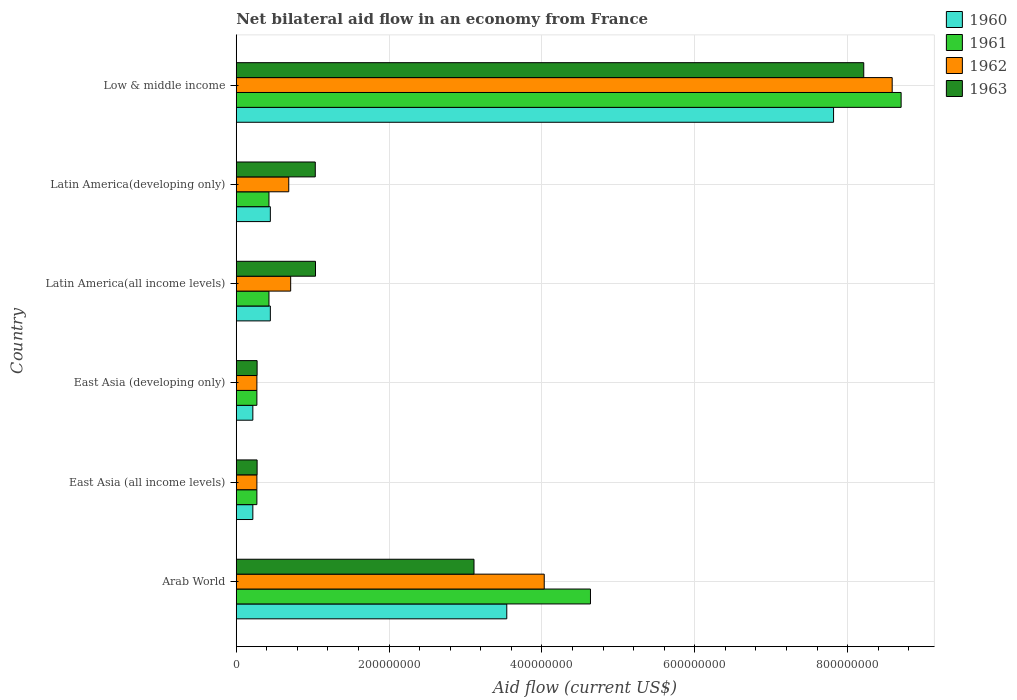Are the number of bars on each tick of the Y-axis equal?
Keep it short and to the point. Yes. How many bars are there on the 3rd tick from the top?
Your response must be concise. 4. What is the label of the 5th group of bars from the top?
Provide a succinct answer. East Asia (all income levels). What is the net bilateral aid flow in 1960 in Latin America(all income levels)?
Provide a succinct answer. 4.46e+07. Across all countries, what is the maximum net bilateral aid flow in 1960?
Your response must be concise. 7.82e+08. Across all countries, what is the minimum net bilateral aid flow in 1962?
Keep it short and to the point. 2.70e+07. In which country was the net bilateral aid flow in 1960 maximum?
Your response must be concise. Low & middle income. In which country was the net bilateral aid flow in 1961 minimum?
Ensure brevity in your answer.  East Asia (all income levels). What is the total net bilateral aid flow in 1961 in the graph?
Provide a succinct answer. 1.47e+09. What is the difference between the net bilateral aid flow in 1961 in East Asia (developing only) and that in Low & middle income?
Provide a short and direct response. -8.43e+08. What is the difference between the net bilateral aid flow in 1962 in Arab World and the net bilateral aid flow in 1960 in Latin America(all income levels)?
Ensure brevity in your answer.  3.58e+08. What is the average net bilateral aid flow in 1962 per country?
Ensure brevity in your answer.  2.43e+08. What is the difference between the net bilateral aid flow in 1960 and net bilateral aid flow in 1963 in East Asia (developing only)?
Your response must be concise. -5.60e+06. In how many countries, is the net bilateral aid flow in 1961 greater than 240000000 US$?
Offer a very short reply. 2. What is the ratio of the net bilateral aid flow in 1961 in Arab World to that in East Asia (developing only)?
Your answer should be compact. 17.17. What is the difference between the highest and the second highest net bilateral aid flow in 1960?
Ensure brevity in your answer.  4.28e+08. What is the difference between the highest and the lowest net bilateral aid flow in 1962?
Keep it short and to the point. 8.31e+08. In how many countries, is the net bilateral aid flow in 1960 greater than the average net bilateral aid flow in 1960 taken over all countries?
Keep it short and to the point. 2. Is the sum of the net bilateral aid flow in 1962 in Latin America(all income levels) and Latin America(developing only) greater than the maximum net bilateral aid flow in 1960 across all countries?
Your response must be concise. No. Is it the case that in every country, the sum of the net bilateral aid flow in 1961 and net bilateral aid flow in 1963 is greater than the sum of net bilateral aid flow in 1962 and net bilateral aid flow in 1960?
Keep it short and to the point. No. Is it the case that in every country, the sum of the net bilateral aid flow in 1962 and net bilateral aid flow in 1963 is greater than the net bilateral aid flow in 1961?
Make the answer very short. Yes. What is the difference between two consecutive major ticks on the X-axis?
Your response must be concise. 2.00e+08. Are the values on the major ticks of X-axis written in scientific E-notation?
Keep it short and to the point. No. Does the graph contain grids?
Ensure brevity in your answer.  Yes. How many legend labels are there?
Your response must be concise. 4. What is the title of the graph?
Give a very brief answer. Net bilateral aid flow in an economy from France. Does "2012" appear as one of the legend labels in the graph?
Provide a succinct answer. No. What is the label or title of the Y-axis?
Make the answer very short. Country. What is the Aid flow (current US$) in 1960 in Arab World?
Your answer should be very brief. 3.54e+08. What is the Aid flow (current US$) in 1961 in Arab World?
Keep it short and to the point. 4.64e+08. What is the Aid flow (current US$) in 1962 in Arab World?
Your answer should be very brief. 4.03e+08. What is the Aid flow (current US$) of 1963 in Arab World?
Your response must be concise. 3.11e+08. What is the Aid flow (current US$) of 1960 in East Asia (all income levels)?
Provide a short and direct response. 2.17e+07. What is the Aid flow (current US$) in 1961 in East Asia (all income levels)?
Your answer should be very brief. 2.70e+07. What is the Aid flow (current US$) in 1962 in East Asia (all income levels)?
Offer a very short reply. 2.70e+07. What is the Aid flow (current US$) in 1963 in East Asia (all income levels)?
Your response must be concise. 2.73e+07. What is the Aid flow (current US$) in 1960 in East Asia (developing only)?
Offer a very short reply. 2.17e+07. What is the Aid flow (current US$) of 1961 in East Asia (developing only)?
Give a very brief answer. 2.70e+07. What is the Aid flow (current US$) of 1962 in East Asia (developing only)?
Offer a very short reply. 2.70e+07. What is the Aid flow (current US$) of 1963 in East Asia (developing only)?
Your response must be concise. 2.73e+07. What is the Aid flow (current US$) in 1960 in Latin America(all income levels)?
Give a very brief answer. 4.46e+07. What is the Aid flow (current US$) of 1961 in Latin America(all income levels)?
Your answer should be very brief. 4.28e+07. What is the Aid flow (current US$) of 1962 in Latin America(all income levels)?
Ensure brevity in your answer.  7.12e+07. What is the Aid flow (current US$) in 1963 in Latin America(all income levels)?
Your response must be concise. 1.04e+08. What is the Aid flow (current US$) in 1960 in Latin America(developing only)?
Offer a very short reply. 4.46e+07. What is the Aid flow (current US$) in 1961 in Latin America(developing only)?
Offer a terse response. 4.28e+07. What is the Aid flow (current US$) of 1962 in Latin America(developing only)?
Keep it short and to the point. 6.87e+07. What is the Aid flow (current US$) in 1963 in Latin America(developing only)?
Provide a succinct answer. 1.03e+08. What is the Aid flow (current US$) in 1960 in Low & middle income?
Keep it short and to the point. 7.82e+08. What is the Aid flow (current US$) in 1961 in Low & middle income?
Your response must be concise. 8.70e+08. What is the Aid flow (current US$) of 1962 in Low & middle income?
Offer a terse response. 8.58e+08. What is the Aid flow (current US$) of 1963 in Low & middle income?
Your answer should be compact. 8.21e+08. Across all countries, what is the maximum Aid flow (current US$) in 1960?
Ensure brevity in your answer.  7.82e+08. Across all countries, what is the maximum Aid flow (current US$) in 1961?
Your answer should be compact. 8.70e+08. Across all countries, what is the maximum Aid flow (current US$) of 1962?
Offer a terse response. 8.58e+08. Across all countries, what is the maximum Aid flow (current US$) in 1963?
Offer a terse response. 8.21e+08. Across all countries, what is the minimum Aid flow (current US$) in 1960?
Your response must be concise. 2.17e+07. Across all countries, what is the minimum Aid flow (current US$) of 1961?
Provide a succinct answer. 2.70e+07. Across all countries, what is the minimum Aid flow (current US$) of 1962?
Your answer should be compact. 2.70e+07. Across all countries, what is the minimum Aid flow (current US$) of 1963?
Give a very brief answer. 2.73e+07. What is the total Aid flow (current US$) of 1960 in the graph?
Ensure brevity in your answer.  1.27e+09. What is the total Aid flow (current US$) of 1961 in the graph?
Your response must be concise. 1.47e+09. What is the total Aid flow (current US$) of 1962 in the graph?
Your answer should be very brief. 1.46e+09. What is the total Aid flow (current US$) in 1963 in the graph?
Offer a terse response. 1.39e+09. What is the difference between the Aid flow (current US$) of 1960 in Arab World and that in East Asia (all income levels)?
Offer a terse response. 3.32e+08. What is the difference between the Aid flow (current US$) of 1961 in Arab World and that in East Asia (all income levels)?
Keep it short and to the point. 4.36e+08. What is the difference between the Aid flow (current US$) of 1962 in Arab World and that in East Asia (all income levels)?
Ensure brevity in your answer.  3.76e+08. What is the difference between the Aid flow (current US$) in 1963 in Arab World and that in East Asia (all income levels)?
Your answer should be very brief. 2.84e+08. What is the difference between the Aid flow (current US$) in 1960 in Arab World and that in East Asia (developing only)?
Offer a very short reply. 3.32e+08. What is the difference between the Aid flow (current US$) of 1961 in Arab World and that in East Asia (developing only)?
Your answer should be very brief. 4.36e+08. What is the difference between the Aid flow (current US$) in 1962 in Arab World and that in East Asia (developing only)?
Provide a succinct answer. 3.76e+08. What is the difference between the Aid flow (current US$) in 1963 in Arab World and that in East Asia (developing only)?
Provide a short and direct response. 2.84e+08. What is the difference between the Aid flow (current US$) of 1960 in Arab World and that in Latin America(all income levels)?
Ensure brevity in your answer.  3.09e+08. What is the difference between the Aid flow (current US$) of 1961 in Arab World and that in Latin America(all income levels)?
Ensure brevity in your answer.  4.21e+08. What is the difference between the Aid flow (current US$) in 1962 in Arab World and that in Latin America(all income levels)?
Offer a terse response. 3.32e+08. What is the difference between the Aid flow (current US$) in 1963 in Arab World and that in Latin America(all income levels)?
Keep it short and to the point. 2.07e+08. What is the difference between the Aid flow (current US$) of 1960 in Arab World and that in Latin America(developing only)?
Keep it short and to the point. 3.09e+08. What is the difference between the Aid flow (current US$) of 1961 in Arab World and that in Latin America(developing only)?
Your response must be concise. 4.21e+08. What is the difference between the Aid flow (current US$) of 1962 in Arab World and that in Latin America(developing only)?
Provide a short and direct response. 3.34e+08. What is the difference between the Aid flow (current US$) of 1963 in Arab World and that in Latin America(developing only)?
Give a very brief answer. 2.08e+08. What is the difference between the Aid flow (current US$) of 1960 in Arab World and that in Low & middle income?
Provide a succinct answer. -4.28e+08. What is the difference between the Aid flow (current US$) of 1961 in Arab World and that in Low & middle income?
Offer a very short reply. -4.06e+08. What is the difference between the Aid flow (current US$) of 1962 in Arab World and that in Low & middle income?
Keep it short and to the point. -4.55e+08. What is the difference between the Aid flow (current US$) of 1963 in Arab World and that in Low & middle income?
Give a very brief answer. -5.10e+08. What is the difference between the Aid flow (current US$) of 1960 in East Asia (all income levels) and that in Latin America(all income levels)?
Keep it short and to the point. -2.29e+07. What is the difference between the Aid flow (current US$) of 1961 in East Asia (all income levels) and that in Latin America(all income levels)?
Provide a short and direct response. -1.58e+07. What is the difference between the Aid flow (current US$) in 1962 in East Asia (all income levels) and that in Latin America(all income levels)?
Provide a short and direct response. -4.42e+07. What is the difference between the Aid flow (current US$) of 1963 in East Asia (all income levels) and that in Latin America(all income levels)?
Your answer should be very brief. -7.64e+07. What is the difference between the Aid flow (current US$) in 1960 in East Asia (all income levels) and that in Latin America(developing only)?
Your answer should be compact. -2.29e+07. What is the difference between the Aid flow (current US$) in 1961 in East Asia (all income levels) and that in Latin America(developing only)?
Offer a terse response. -1.58e+07. What is the difference between the Aid flow (current US$) in 1962 in East Asia (all income levels) and that in Latin America(developing only)?
Your answer should be very brief. -4.17e+07. What is the difference between the Aid flow (current US$) in 1963 in East Asia (all income levels) and that in Latin America(developing only)?
Your answer should be very brief. -7.61e+07. What is the difference between the Aid flow (current US$) in 1960 in East Asia (all income levels) and that in Low & middle income?
Provide a succinct answer. -7.60e+08. What is the difference between the Aid flow (current US$) of 1961 in East Asia (all income levels) and that in Low & middle income?
Keep it short and to the point. -8.43e+08. What is the difference between the Aid flow (current US$) of 1962 in East Asia (all income levels) and that in Low & middle income?
Make the answer very short. -8.31e+08. What is the difference between the Aid flow (current US$) in 1963 in East Asia (all income levels) and that in Low & middle income?
Offer a terse response. -7.94e+08. What is the difference between the Aid flow (current US$) of 1960 in East Asia (developing only) and that in Latin America(all income levels)?
Your answer should be very brief. -2.29e+07. What is the difference between the Aid flow (current US$) of 1961 in East Asia (developing only) and that in Latin America(all income levels)?
Give a very brief answer. -1.58e+07. What is the difference between the Aid flow (current US$) in 1962 in East Asia (developing only) and that in Latin America(all income levels)?
Ensure brevity in your answer.  -4.42e+07. What is the difference between the Aid flow (current US$) of 1963 in East Asia (developing only) and that in Latin America(all income levels)?
Ensure brevity in your answer.  -7.64e+07. What is the difference between the Aid flow (current US$) in 1960 in East Asia (developing only) and that in Latin America(developing only)?
Make the answer very short. -2.29e+07. What is the difference between the Aid flow (current US$) in 1961 in East Asia (developing only) and that in Latin America(developing only)?
Give a very brief answer. -1.58e+07. What is the difference between the Aid flow (current US$) in 1962 in East Asia (developing only) and that in Latin America(developing only)?
Ensure brevity in your answer.  -4.17e+07. What is the difference between the Aid flow (current US$) of 1963 in East Asia (developing only) and that in Latin America(developing only)?
Keep it short and to the point. -7.61e+07. What is the difference between the Aid flow (current US$) of 1960 in East Asia (developing only) and that in Low & middle income?
Your response must be concise. -7.60e+08. What is the difference between the Aid flow (current US$) of 1961 in East Asia (developing only) and that in Low & middle income?
Keep it short and to the point. -8.43e+08. What is the difference between the Aid flow (current US$) of 1962 in East Asia (developing only) and that in Low & middle income?
Provide a succinct answer. -8.31e+08. What is the difference between the Aid flow (current US$) of 1963 in East Asia (developing only) and that in Low & middle income?
Offer a terse response. -7.94e+08. What is the difference between the Aid flow (current US$) of 1961 in Latin America(all income levels) and that in Latin America(developing only)?
Offer a very short reply. 0. What is the difference between the Aid flow (current US$) of 1962 in Latin America(all income levels) and that in Latin America(developing only)?
Provide a succinct answer. 2.50e+06. What is the difference between the Aid flow (current US$) of 1960 in Latin America(all income levels) and that in Low & middle income?
Ensure brevity in your answer.  -7.37e+08. What is the difference between the Aid flow (current US$) of 1961 in Latin America(all income levels) and that in Low & middle income?
Ensure brevity in your answer.  -8.27e+08. What is the difference between the Aid flow (current US$) in 1962 in Latin America(all income levels) and that in Low & middle income?
Provide a succinct answer. -7.87e+08. What is the difference between the Aid flow (current US$) of 1963 in Latin America(all income levels) and that in Low & middle income?
Give a very brief answer. -7.17e+08. What is the difference between the Aid flow (current US$) of 1960 in Latin America(developing only) and that in Low & middle income?
Offer a very short reply. -7.37e+08. What is the difference between the Aid flow (current US$) in 1961 in Latin America(developing only) and that in Low & middle income?
Offer a very short reply. -8.27e+08. What is the difference between the Aid flow (current US$) of 1962 in Latin America(developing only) and that in Low & middle income?
Provide a short and direct response. -7.90e+08. What is the difference between the Aid flow (current US$) in 1963 in Latin America(developing only) and that in Low & middle income?
Your response must be concise. -7.18e+08. What is the difference between the Aid flow (current US$) in 1960 in Arab World and the Aid flow (current US$) in 1961 in East Asia (all income levels)?
Provide a short and direct response. 3.27e+08. What is the difference between the Aid flow (current US$) of 1960 in Arab World and the Aid flow (current US$) of 1962 in East Asia (all income levels)?
Offer a very short reply. 3.27e+08. What is the difference between the Aid flow (current US$) in 1960 in Arab World and the Aid flow (current US$) in 1963 in East Asia (all income levels)?
Your answer should be compact. 3.27e+08. What is the difference between the Aid flow (current US$) in 1961 in Arab World and the Aid flow (current US$) in 1962 in East Asia (all income levels)?
Offer a terse response. 4.36e+08. What is the difference between the Aid flow (current US$) of 1961 in Arab World and the Aid flow (current US$) of 1963 in East Asia (all income levels)?
Ensure brevity in your answer.  4.36e+08. What is the difference between the Aid flow (current US$) in 1962 in Arab World and the Aid flow (current US$) in 1963 in East Asia (all income levels)?
Offer a terse response. 3.76e+08. What is the difference between the Aid flow (current US$) in 1960 in Arab World and the Aid flow (current US$) in 1961 in East Asia (developing only)?
Your response must be concise. 3.27e+08. What is the difference between the Aid flow (current US$) of 1960 in Arab World and the Aid flow (current US$) of 1962 in East Asia (developing only)?
Offer a very short reply. 3.27e+08. What is the difference between the Aid flow (current US$) in 1960 in Arab World and the Aid flow (current US$) in 1963 in East Asia (developing only)?
Give a very brief answer. 3.27e+08. What is the difference between the Aid flow (current US$) of 1961 in Arab World and the Aid flow (current US$) of 1962 in East Asia (developing only)?
Give a very brief answer. 4.36e+08. What is the difference between the Aid flow (current US$) of 1961 in Arab World and the Aid flow (current US$) of 1963 in East Asia (developing only)?
Ensure brevity in your answer.  4.36e+08. What is the difference between the Aid flow (current US$) of 1962 in Arab World and the Aid flow (current US$) of 1963 in East Asia (developing only)?
Give a very brief answer. 3.76e+08. What is the difference between the Aid flow (current US$) of 1960 in Arab World and the Aid flow (current US$) of 1961 in Latin America(all income levels)?
Provide a succinct answer. 3.11e+08. What is the difference between the Aid flow (current US$) of 1960 in Arab World and the Aid flow (current US$) of 1962 in Latin America(all income levels)?
Provide a succinct answer. 2.83e+08. What is the difference between the Aid flow (current US$) of 1960 in Arab World and the Aid flow (current US$) of 1963 in Latin America(all income levels)?
Your response must be concise. 2.50e+08. What is the difference between the Aid flow (current US$) of 1961 in Arab World and the Aid flow (current US$) of 1962 in Latin America(all income levels)?
Give a very brief answer. 3.92e+08. What is the difference between the Aid flow (current US$) of 1961 in Arab World and the Aid flow (current US$) of 1963 in Latin America(all income levels)?
Provide a short and direct response. 3.60e+08. What is the difference between the Aid flow (current US$) in 1962 in Arab World and the Aid flow (current US$) in 1963 in Latin America(all income levels)?
Provide a short and direct response. 2.99e+08. What is the difference between the Aid flow (current US$) of 1960 in Arab World and the Aid flow (current US$) of 1961 in Latin America(developing only)?
Offer a very short reply. 3.11e+08. What is the difference between the Aid flow (current US$) of 1960 in Arab World and the Aid flow (current US$) of 1962 in Latin America(developing only)?
Provide a short and direct response. 2.85e+08. What is the difference between the Aid flow (current US$) of 1960 in Arab World and the Aid flow (current US$) of 1963 in Latin America(developing only)?
Offer a very short reply. 2.51e+08. What is the difference between the Aid flow (current US$) of 1961 in Arab World and the Aid flow (current US$) of 1962 in Latin America(developing only)?
Your answer should be compact. 3.95e+08. What is the difference between the Aid flow (current US$) in 1961 in Arab World and the Aid flow (current US$) in 1963 in Latin America(developing only)?
Your answer should be compact. 3.60e+08. What is the difference between the Aid flow (current US$) of 1962 in Arab World and the Aid flow (current US$) of 1963 in Latin America(developing only)?
Give a very brief answer. 3.00e+08. What is the difference between the Aid flow (current US$) in 1960 in Arab World and the Aid flow (current US$) in 1961 in Low & middle income?
Ensure brevity in your answer.  -5.16e+08. What is the difference between the Aid flow (current US$) of 1960 in Arab World and the Aid flow (current US$) of 1962 in Low & middle income?
Your answer should be compact. -5.04e+08. What is the difference between the Aid flow (current US$) of 1960 in Arab World and the Aid flow (current US$) of 1963 in Low & middle income?
Offer a very short reply. -4.67e+08. What is the difference between the Aid flow (current US$) of 1961 in Arab World and the Aid flow (current US$) of 1962 in Low & middle income?
Keep it short and to the point. -3.95e+08. What is the difference between the Aid flow (current US$) of 1961 in Arab World and the Aid flow (current US$) of 1963 in Low & middle income?
Make the answer very short. -3.58e+08. What is the difference between the Aid flow (current US$) of 1962 in Arab World and the Aid flow (current US$) of 1963 in Low & middle income?
Ensure brevity in your answer.  -4.18e+08. What is the difference between the Aid flow (current US$) in 1960 in East Asia (all income levels) and the Aid flow (current US$) in 1961 in East Asia (developing only)?
Provide a succinct answer. -5.30e+06. What is the difference between the Aid flow (current US$) in 1960 in East Asia (all income levels) and the Aid flow (current US$) in 1962 in East Asia (developing only)?
Keep it short and to the point. -5.30e+06. What is the difference between the Aid flow (current US$) in 1960 in East Asia (all income levels) and the Aid flow (current US$) in 1963 in East Asia (developing only)?
Your answer should be very brief. -5.60e+06. What is the difference between the Aid flow (current US$) of 1961 in East Asia (all income levels) and the Aid flow (current US$) of 1962 in East Asia (developing only)?
Keep it short and to the point. 0. What is the difference between the Aid flow (current US$) in 1962 in East Asia (all income levels) and the Aid flow (current US$) in 1963 in East Asia (developing only)?
Ensure brevity in your answer.  -3.00e+05. What is the difference between the Aid flow (current US$) in 1960 in East Asia (all income levels) and the Aid flow (current US$) in 1961 in Latin America(all income levels)?
Make the answer very short. -2.11e+07. What is the difference between the Aid flow (current US$) in 1960 in East Asia (all income levels) and the Aid flow (current US$) in 1962 in Latin America(all income levels)?
Provide a succinct answer. -4.95e+07. What is the difference between the Aid flow (current US$) in 1960 in East Asia (all income levels) and the Aid flow (current US$) in 1963 in Latin America(all income levels)?
Ensure brevity in your answer.  -8.20e+07. What is the difference between the Aid flow (current US$) in 1961 in East Asia (all income levels) and the Aid flow (current US$) in 1962 in Latin America(all income levels)?
Make the answer very short. -4.42e+07. What is the difference between the Aid flow (current US$) in 1961 in East Asia (all income levels) and the Aid flow (current US$) in 1963 in Latin America(all income levels)?
Provide a succinct answer. -7.67e+07. What is the difference between the Aid flow (current US$) in 1962 in East Asia (all income levels) and the Aid flow (current US$) in 1963 in Latin America(all income levels)?
Ensure brevity in your answer.  -7.67e+07. What is the difference between the Aid flow (current US$) of 1960 in East Asia (all income levels) and the Aid flow (current US$) of 1961 in Latin America(developing only)?
Ensure brevity in your answer.  -2.11e+07. What is the difference between the Aid flow (current US$) of 1960 in East Asia (all income levels) and the Aid flow (current US$) of 1962 in Latin America(developing only)?
Give a very brief answer. -4.70e+07. What is the difference between the Aid flow (current US$) of 1960 in East Asia (all income levels) and the Aid flow (current US$) of 1963 in Latin America(developing only)?
Give a very brief answer. -8.17e+07. What is the difference between the Aid flow (current US$) in 1961 in East Asia (all income levels) and the Aid flow (current US$) in 1962 in Latin America(developing only)?
Your response must be concise. -4.17e+07. What is the difference between the Aid flow (current US$) in 1961 in East Asia (all income levels) and the Aid flow (current US$) in 1963 in Latin America(developing only)?
Your response must be concise. -7.64e+07. What is the difference between the Aid flow (current US$) of 1962 in East Asia (all income levels) and the Aid flow (current US$) of 1963 in Latin America(developing only)?
Provide a succinct answer. -7.64e+07. What is the difference between the Aid flow (current US$) of 1960 in East Asia (all income levels) and the Aid flow (current US$) of 1961 in Low & middle income?
Make the answer very short. -8.48e+08. What is the difference between the Aid flow (current US$) of 1960 in East Asia (all income levels) and the Aid flow (current US$) of 1962 in Low & middle income?
Your answer should be compact. -8.37e+08. What is the difference between the Aid flow (current US$) in 1960 in East Asia (all income levels) and the Aid flow (current US$) in 1963 in Low & middle income?
Offer a very short reply. -7.99e+08. What is the difference between the Aid flow (current US$) in 1961 in East Asia (all income levels) and the Aid flow (current US$) in 1962 in Low & middle income?
Keep it short and to the point. -8.31e+08. What is the difference between the Aid flow (current US$) of 1961 in East Asia (all income levels) and the Aid flow (current US$) of 1963 in Low & middle income?
Your answer should be compact. -7.94e+08. What is the difference between the Aid flow (current US$) in 1962 in East Asia (all income levels) and the Aid flow (current US$) in 1963 in Low & middle income?
Provide a succinct answer. -7.94e+08. What is the difference between the Aid flow (current US$) of 1960 in East Asia (developing only) and the Aid flow (current US$) of 1961 in Latin America(all income levels)?
Your answer should be very brief. -2.11e+07. What is the difference between the Aid flow (current US$) in 1960 in East Asia (developing only) and the Aid flow (current US$) in 1962 in Latin America(all income levels)?
Make the answer very short. -4.95e+07. What is the difference between the Aid flow (current US$) in 1960 in East Asia (developing only) and the Aid flow (current US$) in 1963 in Latin America(all income levels)?
Make the answer very short. -8.20e+07. What is the difference between the Aid flow (current US$) in 1961 in East Asia (developing only) and the Aid flow (current US$) in 1962 in Latin America(all income levels)?
Give a very brief answer. -4.42e+07. What is the difference between the Aid flow (current US$) in 1961 in East Asia (developing only) and the Aid flow (current US$) in 1963 in Latin America(all income levels)?
Keep it short and to the point. -7.67e+07. What is the difference between the Aid flow (current US$) of 1962 in East Asia (developing only) and the Aid flow (current US$) of 1963 in Latin America(all income levels)?
Your response must be concise. -7.67e+07. What is the difference between the Aid flow (current US$) in 1960 in East Asia (developing only) and the Aid flow (current US$) in 1961 in Latin America(developing only)?
Your answer should be very brief. -2.11e+07. What is the difference between the Aid flow (current US$) in 1960 in East Asia (developing only) and the Aid flow (current US$) in 1962 in Latin America(developing only)?
Your response must be concise. -4.70e+07. What is the difference between the Aid flow (current US$) of 1960 in East Asia (developing only) and the Aid flow (current US$) of 1963 in Latin America(developing only)?
Your answer should be very brief. -8.17e+07. What is the difference between the Aid flow (current US$) in 1961 in East Asia (developing only) and the Aid flow (current US$) in 1962 in Latin America(developing only)?
Offer a very short reply. -4.17e+07. What is the difference between the Aid flow (current US$) in 1961 in East Asia (developing only) and the Aid flow (current US$) in 1963 in Latin America(developing only)?
Ensure brevity in your answer.  -7.64e+07. What is the difference between the Aid flow (current US$) in 1962 in East Asia (developing only) and the Aid flow (current US$) in 1963 in Latin America(developing only)?
Give a very brief answer. -7.64e+07. What is the difference between the Aid flow (current US$) in 1960 in East Asia (developing only) and the Aid flow (current US$) in 1961 in Low & middle income?
Keep it short and to the point. -8.48e+08. What is the difference between the Aid flow (current US$) in 1960 in East Asia (developing only) and the Aid flow (current US$) in 1962 in Low & middle income?
Keep it short and to the point. -8.37e+08. What is the difference between the Aid flow (current US$) of 1960 in East Asia (developing only) and the Aid flow (current US$) of 1963 in Low & middle income?
Your answer should be compact. -7.99e+08. What is the difference between the Aid flow (current US$) of 1961 in East Asia (developing only) and the Aid flow (current US$) of 1962 in Low & middle income?
Ensure brevity in your answer.  -8.31e+08. What is the difference between the Aid flow (current US$) in 1961 in East Asia (developing only) and the Aid flow (current US$) in 1963 in Low & middle income?
Ensure brevity in your answer.  -7.94e+08. What is the difference between the Aid flow (current US$) in 1962 in East Asia (developing only) and the Aid flow (current US$) in 1963 in Low & middle income?
Your answer should be compact. -7.94e+08. What is the difference between the Aid flow (current US$) in 1960 in Latin America(all income levels) and the Aid flow (current US$) in 1961 in Latin America(developing only)?
Offer a very short reply. 1.80e+06. What is the difference between the Aid flow (current US$) of 1960 in Latin America(all income levels) and the Aid flow (current US$) of 1962 in Latin America(developing only)?
Give a very brief answer. -2.41e+07. What is the difference between the Aid flow (current US$) in 1960 in Latin America(all income levels) and the Aid flow (current US$) in 1963 in Latin America(developing only)?
Ensure brevity in your answer.  -5.88e+07. What is the difference between the Aid flow (current US$) in 1961 in Latin America(all income levels) and the Aid flow (current US$) in 1962 in Latin America(developing only)?
Offer a terse response. -2.59e+07. What is the difference between the Aid flow (current US$) of 1961 in Latin America(all income levels) and the Aid flow (current US$) of 1963 in Latin America(developing only)?
Make the answer very short. -6.06e+07. What is the difference between the Aid flow (current US$) in 1962 in Latin America(all income levels) and the Aid flow (current US$) in 1963 in Latin America(developing only)?
Keep it short and to the point. -3.22e+07. What is the difference between the Aid flow (current US$) in 1960 in Latin America(all income levels) and the Aid flow (current US$) in 1961 in Low & middle income?
Keep it short and to the point. -8.25e+08. What is the difference between the Aid flow (current US$) of 1960 in Latin America(all income levels) and the Aid flow (current US$) of 1962 in Low & middle income?
Keep it short and to the point. -8.14e+08. What is the difference between the Aid flow (current US$) of 1960 in Latin America(all income levels) and the Aid flow (current US$) of 1963 in Low & middle income?
Keep it short and to the point. -7.76e+08. What is the difference between the Aid flow (current US$) of 1961 in Latin America(all income levels) and the Aid flow (current US$) of 1962 in Low & middle income?
Provide a succinct answer. -8.16e+08. What is the difference between the Aid flow (current US$) in 1961 in Latin America(all income levels) and the Aid flow (current US$) in 1963 in Low & middle income?
Provide a succinct answer. -7.78e+08. What is the difference between the Aid flow (current US$) in 1962 in Latin America(all income levels) and the Aid flow (current US$) in 1963 in Low & middle income?
Make the answer very short. -7.50e+08. What is the difference between the Aid flow (current US$) of 1960 in Latin America(developing only) and the Aid flow (current US$) of 1961 in Low & middle income?
Ensure brevity in your answer.  -8.25e+08. What is the difference between the Aid flow (current US$) of 1960 in Latin America(developing only) and the Aid flow (current US$) of 1962 in Low & middle income?
Provide a succinct answer. -8.14e+08. What is the difference between the Aid flow (current US$) in 1960 in Latin America(developing only) and the Aid flow (current US$) in 1963 in Low & middle income?
Give a very brief answer. -7.76e+08. What is the difference between the Aid flow (current US$) of 1961 in Latin America(developing only) and the Aid flow (current US$) of 1962 in Low & middle income?
Make the answer very short. -8.16e+08. What is the difference between the Aid flow (current US$) of 1961 in Latin America(developing only) and the Aid flow (current US$) of 1963 in Low & middle income?
Provide a succinct answer. -7.78e+08. What is the difference between the Aid flow (current US$) of 1962 in Latin America(developing only) and the Aid flow (current US$) of 1963 in Low & middle income?
Ensure brevity in your answer.  -7.52e+08. What is the average Aid flow (current US$) in 1960 per country?
Offer a terse response. 2.11e+08. What is the average Aid flow (current US$) in 1961 per country?
Provide a short and direct response. 2.46e+08. What is the average Aid flow (current US$) of 1962 per country?
Offer a terse response. 2.43e+08. What is the average Aid flow (current US$) in 1963 per country?
Ensure brevity in your answer.  2.32e+08. What is the difference between the Aid flow (current US$) in 1960 and Aid flow (current US$) in 1961 in Arab World?
Keep it short and to the point. -1.10e+08. What is the difference between the Aid flow (current US$) of 1960 and Aid flow (current US$) of 1962 in Arab World?
Your answer should be very brief. -4.90e+07. What is the difference between the Aid flow (current US$) in 1960 and Aid flow (current US$) in 1963 in Arab World?
Make the answer very short. 4.29e+07. What is the difference between the Aid flow (current US$) of 1961 and Aid flow (current US$) of 1962 in Arab World?
Give a very brief answer. 6.05e+07. What is the difference between the Aid flow (current US$) in 1961 and Aid flow (current US$) in 1963 in Arab World?
Your answer should be very brief. 1.52e+08. What is the difference between the Aid flow (current US$) of 1962 and Aid flow (current US$) of 1963 in Arab World?
Give a very brief answer. 9.19e+07. What is the difference between the Aid flow (current US$) in 1960 and Aid flow (current US$) in 1961 in East Asia (all income levels)?
Your response must be concise. -5.30e+06. What is the difference between the Aid flow (current US$) of 1960 and Aid flow (current US$) of 1962 in East Asia (all income levels)?
Offer a very short reply. -5.30e+06. What is the difference between the Aid flow (current US$) of 1960 and Aid flow (current US$) of 1963 in East Asia (all income levels)?
Offer a very short reply. -5.60e+06. What is the difference between the Aid flow (current US$) of 1961 and Aid flow (current US$) of 1963 in East Asia (all income levels)?
Your response must be concise. -3.00e+05. What is the difference between the Aid flow (current US$) of 1962 and Aid flow (current US$) of 1963 in East Asia (all income levels)?
Your response must be concise. -3.00e+05. What is the difference between the Aid flow (current US$) of 1960 and Aid flow (current US$) of 1961 in East Asia (developing only)?
Offer a terse response. -5.30e+06. What is the difference between the Aid flow (current US$) of 1960 and Aid flow (current US$) of 1962 in East Asia (developing only)?
Make the answer very short. -5.30e+06. What is the difference between the Aid flow (current US$) of 1960 and Aid flow (current US$) of 1963 in East Asia (developing only)?
Keep it short and to the point. -5.60e+06. What is the difference between the Aid flow (current US$) of 1961 and Aid flow (current US$) of 1962 in East Asia (developing only)?
Your response must be concise. 0. What is the difference between the Aid flow (current US$) in 1962 and Aid flow (current US$) in 1963 in East Asia (developing only)?
Offer a very short reply. -3.00e+05. What is the difference between the Aid flow (current US$) in 1960 and Aid flow (current US$) in 1961 in Latin America(all income levels)?
Your answer should be compact. 1.80e+06. What is the difference between the Aid flow (current US$) in 1960 and Aid flow (current US$) in 1962 in Latin America(all income levels)?
Make the answer very short. -2.66e+07. What is the difference between the Aid flow (current US$) of 1960 and Aid flow (current US$) of 1963 in Latin America(all income levels)?
Offer a very short reply. -5.91e+07. What is the difference between the Aid flow (current US$) in 1961 and Aid flow (current US$) in 1962 in Latin America(all income levels)?
Give a very brief answer. -2.84e+07. What is the difference between the Aid flow (current US$) of 1961 and Aid flow (current US$) of 1963 in Latin America(all income levels)?
Ensure brevity in your answer.  -6.09e+07. What is the difference between the Aid flow (current US$) of 1962 and Aid flow (current US$) of 1963 in Latin America(all income levels)?
Keep it short and to the point. -3.25e+07. What is the difference between the Aid flow (current US$) in 1960 and Aid flow (current US$) in 1961 in Latin America(developing only)?
Give a very brief answer. 1.80e+06. What is the difference between the Aid flow (current US$) in 1960 and Aid flow (current US$) in 1962 in Latin America(developing only)?
Offer a terse response. -2.41e+07. What is the difference between the Aid flow (current US$) in 1960 and Aid flow (current US$) in 1963 in Latin America(developing only)?
Offer a very short reply. -5.88e+07. What is the difference between the Aid flow (current US$) in 1961 and Aid flow (current US$) in 1962 in Latin America(developing only)?
Keep it short and to the point. -2.59e+07. What is the difference between the Aid flow (current US$) of 1961 and Aid flow (current US$) of 1963 in Latin America(developing only)?
Offer a very short reply. -6.06e+07. What is the difference between the Aid flow (current US$) in 1962 and Aid flow (current US$) in 1963 in Latin America(developing only)?
Your answer should be very brief. -3.47e+07. What is the difference between the Aid flow (current US$) of 1960 and Aid flow (current US$) of 1961 in Low & middle income?
Ensure brevity in your answer.  -8.84e+07. What is the difference between the Aid flow (current US$) of 1960 and Aid flow (current US$) of 1962 in Low & middle income?
Your answer should be very brief. -7.67e+07. What is the difference between the Aid flow (current US$) in 1960 and Aid flow (current US$) in 1963 in Low & middle income?
Provide a short and direct response. -3.95e+07. What is the difference between the Aid flow (current US$) in 1961 and Aid flow (current US$) in 1962 in Low & middle income?
Offer a terse response. 1.17e+07. What is the difference between the Aid flow (current US$) of 1961 and Aid flow (current US$) of 1963 in Low & middle income?
Your response must be concise. 4.89e+07. What is the difference between the Aid flow (current US$) of 1962 and Aid flow (current US$) of 1963 in Low & middle income?
Keep it short and to the point. 3.72e+07. What is the ratio of the Aid flow (current US$) in 1960 in Arab World to that in East Asia (all income levels)?
Offer a terse response. 16.31. What is the ratio of the Aid flow (current US$) in 1961 in Arab World to that in East Asia (all income levels)?
Your answer should be very brief. 17.17. What is the ratio of the Aid flow (current US$) in 1962 in Arab World to that in East Asia (all income levels)?
Provide a succinct answer. 14.93. What is the ratio of the Aid flow (current US$) of 1963 in Arab World to that in East Asia (all income levels)?
Provide a succinct answer. 11.4. What is the ratio of the Aid flow (current US$) of 1960 in Arab World to that in East Asia (developing only)?
Provide a succinct answer. 16.31. What is the ratio of the Aid flow (current US$) in 1961 in Arab World to that in East Asia (developing only)?
Your answer should be compact. 17.17. What is the ratio of the Aid flow (current US$) in 1962 in Arab World to that in East Asia (developing only)?
Keep it short and to the point. 14.93. What is the ratio of the Aid flow (current US$) in 1963 in Arab World to that in East Asia (developing only)?
Your response must be concise. 11.4. What is the ratio of the Aid flow (current US$) in 1960 in Arab World to that in Latin America(all income levels)?
Your answer should be compact. 7.94. What is the ratio of the Aid flow (current US$) in 1961 in Arab World to that in Latin America(all income levels)?
Keep it short and to the point. 10.83. What is the ratio of the Aid flow (current US$) in 1962 in Arab World to that in Latin America(all income levels)?
Your answer should be compact. 5.66. What is the ratio of the Aid flow (current US$) in 1960 in Arab World to that in Latin America(developing only)?
Ensure brevity in your answer.  7.94. What is the ratio of the Aid flow (current US$) in 1961 in Arab World to that in Latin America(developing only)?
Make the answer very short. 10.83. What is the ratio of the Aid flow (current US$) of 1962 in Arab World to that in Latin America(developing only)?
Provide a short and direct response. 5.87. What is the ratio of the Aid flow (current US$) in 1963 in Arab World to that in Latin America(developing only)?
Provide a succinct answer. 3.01. What is the ratio of the Aid flow (current US$) of 1960 in Arab World to that in Low & middle income?
Give a very brief answer. 0.45. What is the ratio of the Aid flow (current US$) in 1961 in Arab World to that in Low & middle income?
Your answer should be very brief. 0.53. What is the ratio of the Aid flow (current US$) in 1962 in Arab World to that in Low & middle income?
Your response must be concise. 0.47. What is the ratio of the Aid flow (current US$) of 1963 in Arab World to that in Low & middle income?
Make the answer very short. 0.38. What is the ratio of the Aid flow (current US$) in 1960 in East Asia (all income levels) to that in East Asia (developing only)?
Offer a terse response. 1. What is the ratio of the Aid flow (current US$) of 1961 in East Asia (all income levels) to that in East Asia (developing only)?
Give a very brief answer. 1. What is the ratio of the Aid flow (current US$) in 1962 in East Asia (all income levels) to that in East Asia (developing only)?
Your answer should be compact. 1. What is the ratio of the Aid flow (current US$) in 1963 in East Asia (all income levels) to that in East Asia (developing only)?
Make the answer very short. 1. What is the ratio of the Aid flow (current US$) in 1960 in East Asia (all income levels) to that in Latin America(all income levels)?
Provide a succinct answer. 0.49. What is the ratio of the Aid flow (current US$) in 1961 in East Asia (all income levels) to that in Latin America(all income levels)?
Offer a very short reply. 0.63. What is the ratio of the Aid flow (current US$) of 1962 in East Asia (all income levels) to that in Latin America(all income levels)?
Your answer should be very brief. 0.38. What is the ratio of the Aid flow (current US$) of 1963 in East Asia (all income levels) to that in Latin America(all income levels)?
Offer a very short reply. 0.26. What is the ratio of the Aid flow (current US$) in 1960 in East Asia (all income levels) to that in Latin America(developing only)?
Your answer should be very brief. 0.49. What is the ratio of the Aid flow (current US$) of 1961 in East Asia (all income levels) to that in Latin America(developing only)?
Offer a terse response. 0.63. What is the ratio of the Aid flow (current US$) of 1962 in East Asia (all income levels) to that in Latin America(developing only)?
Provide a short and direct response. 0.39. What is the ratio of the Aid flow (current US$) of 1963 in East Asia (all income levels) to that in Latin America(developing only)?
Provide a succinct answer. 0.26. What is the ratio of the Aid flow (current US$) of 1960 in East Asia (all income levels) to that in Low & middle income?
Provide a short and direct response. 0.03. What is the ratio of the Aid flow (current US$) of 1961 in East Asia (all income levels) to that in Low & middle income?
Your answer should be compact. 0.03. What is the ratio of the Aid flow (current US$) of 1962 in East Asia (all income levels) to that in Low & middle income?
Provide a succinct answer. 0.03. What is the ratio of the Aid flow (current US$) of 1963 in East Asia (all income levels) to that in Low & middle income?
Ensure brevity in your answer.  0.03. What is the ratio of the Aid flow (current US$) of 1960 in East Asia (developing only) to that in Latin America(all income levels)?
Provide a succinct answer. 0.49. What is the ratio of the Aid flow (current US$) of 1961 in East Asia (developing only) to that in Latin America(all income levels)?
Your response must be concise. 0.63. What is the ratio of the Aid flow (current US$) in 1962 in East Asia (developing only) to that in Latin America(all income levels)?
Make the answer very short. 0.38. What is the ratio of the Aid flow (current US$) in 1963 in East Asia (developing only) to that in Latin America(all income levels)?
Your answer should be very brief. 0.26. What is the ratio of the Aid flow (current US$) in 1960 in East Asia (developing only) to that in Latin America(developing only)?
Your answer should be very brief. 0.49. What is the ratio of the Aid flow (current US$) of 1961 in East Asia (developing only) to that in Latin America(developing only)?
Ensure brevity in your answer.  0.63. What is the ratio of the Aid flow (current US$) in 1962 in East Asia (developing only) to that in Latin America(developing only)?
Provide a short and direct response. 0.39. What is the ratio of the Aid flow (current US$) of 1963 in East Asia (developing only) to that in Latin America(developing only)?
Your answer should be compact. 0.26. What is the ratio of the Aid flow (current US$) of 1960 in East Asia (developing only) to that in Low & middle income?
Provide a short and direct response. 0.03. What is the ratio of the Aid flow (current US$) in 1961 in East Asia (developing only) to that in Low & middle income?
Make the answer very short. 0.03. What is the ratio of the Aid flow (current US$) in 1962 in East Asia (developing only) to that in Low & middle income?
Provide a short and direct response. 0.03. What is the ratio of the Aid flow (current US$) of 1963 in East Asia (developing only) to that in Low & middle income?
Make the answer very short. 0.03. What is the ratio of the Aid flow (current US$) of 1961 in Latin America(all income levels) to that in Latin America(developing only)?
Make the answer very short. 1. What is the ratio of the Aid flow (current US$) in 1962 in Latin America(all income levels) to that in Latin America(developing only)?
Your response must be concise. 1.04. What is the ratio of the Aid flow (current US$) in 1963 in Latin America(all income levels) to that in Latin America(developing only)?
Offer a very short reply. 1. What is the ratio of the Aid flow (current US$) in 1960 in Latin America(all income levels) to that in Low & middle income?
Your answer should be compact. 0.06. What is the ratio of the Aid flow (current US$) of 1961 in Latin America(all income levels) to that in Low & middle income?
Keep it short and to the point. 0.05. What is the ratio of the Aid flow (current US$) of 1962 in Latin America(all income levels) to that in Low & middle income?
Make the answer very short. 0.08. What is the ratio of the Aid flow (current US$) in 1963 in Latin America(all income levels) to that in Low & middle income?
Ensure brevity in your answer.  0.13. What is the ratio of the Aid flow (current US$) of 1960 in Latin America(developing only) to that in Low & middle income?
Your response must be concise. 0.06. What is the ratio of the Aid flow (current US$) of 1961 in Latin America(developing only) to that in Low & middle income?
Keep it short and to the point. 0.05. What is the ratio of the Aid flow (current US$) of 1962 in Latin America(developing only) to that in Low & middle income?
Your answer should be compact. 0.08. What is the ratio of the Aid flow (current US$) of 1963 in Latin America(developing only) to that in Low & middle income?
Give a very brief answer. 0.13. What is the difference between the highest and the second highest Aid flow (current US$) of 1960?
Your response must be concise. 4.28e+08. What is the difference between the highest and the second highest Aid flow (current US$) in 1961?
Ensure brevity in your answer.  4.06e+08. What is the difference between the highest and the second highest Aid flow (current US$) in 1962?
Offer a very short reply. 4.55e+08. What is the difference between the highest and the second highest Aid flow (current US$) of 1963?
Provide a short and direct response. 5.10e+08. What is the difference between the highest and the lowest Aid flow (current US$) of 1960?
Your answer should be compact. 7.60e+08. What is the difference between the highest and the lowest Aid flow (current US$) of 1961?
Your answer should be compact. 8.43e+08. What is the difference between the highest and the lowest Aid flow (current US$) of 1962?
Provide a succinct answer. 8.31e+08. What is the difference between the highest and the lowest Aid flow (current US$) in 1963?
Provide a short and direct response. 7.94e+08. 